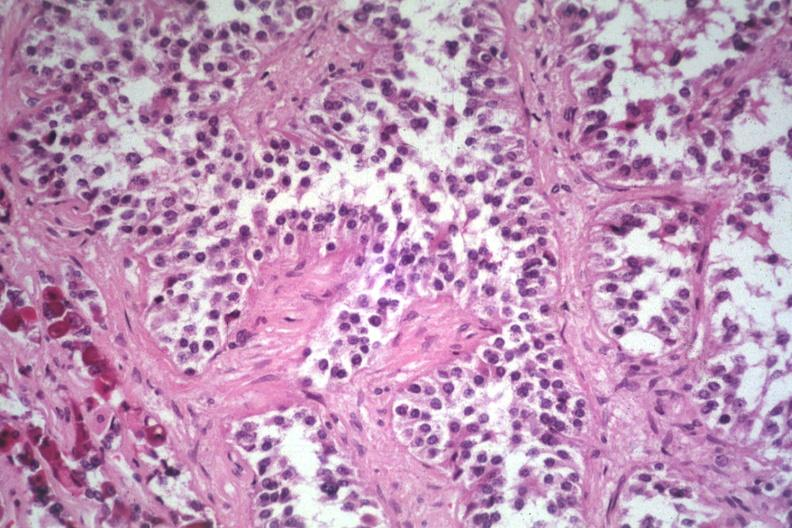does acute lymphocytic leukemia show papillary lesion unusual?
Answer the question using a single word or phrase. No 